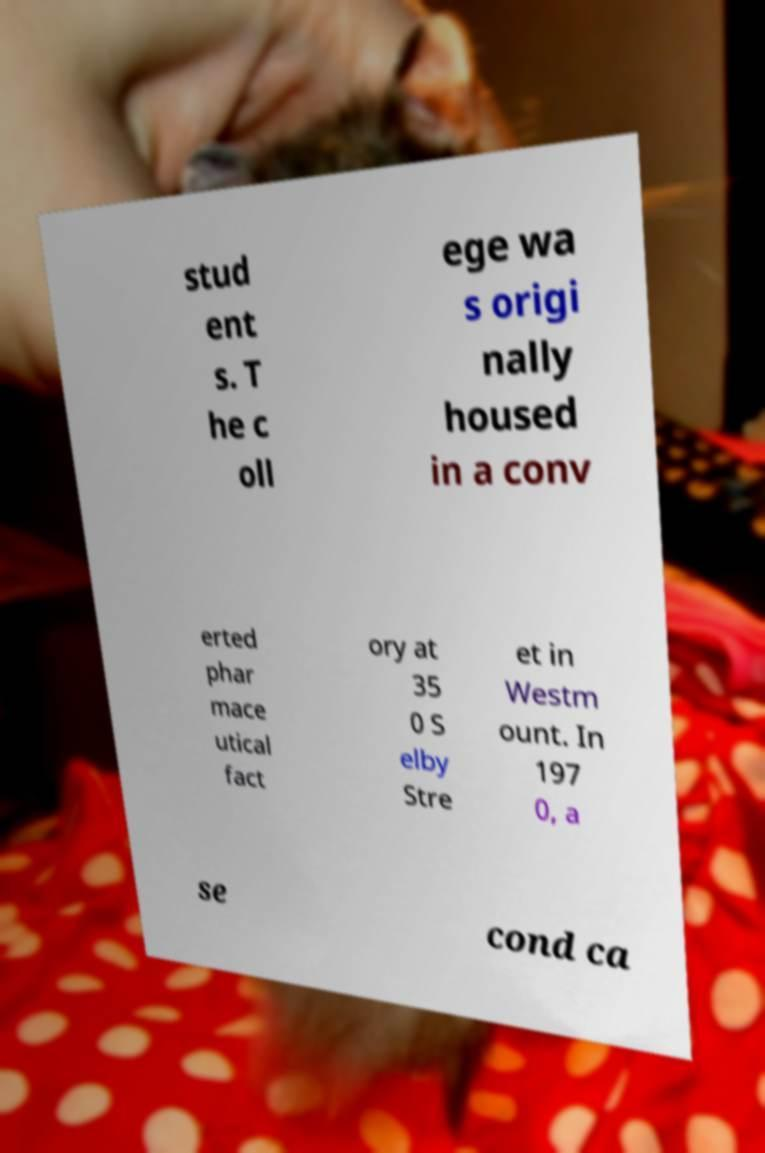I need the written content from this picture converted into text. Can you do that? stud ent s. T he c oll ege wa s origi nally housed in a conv erted phar mace utical fact ory at 35 0 S elby Stre et in Westm ount. In 197 0, a se cond ca 